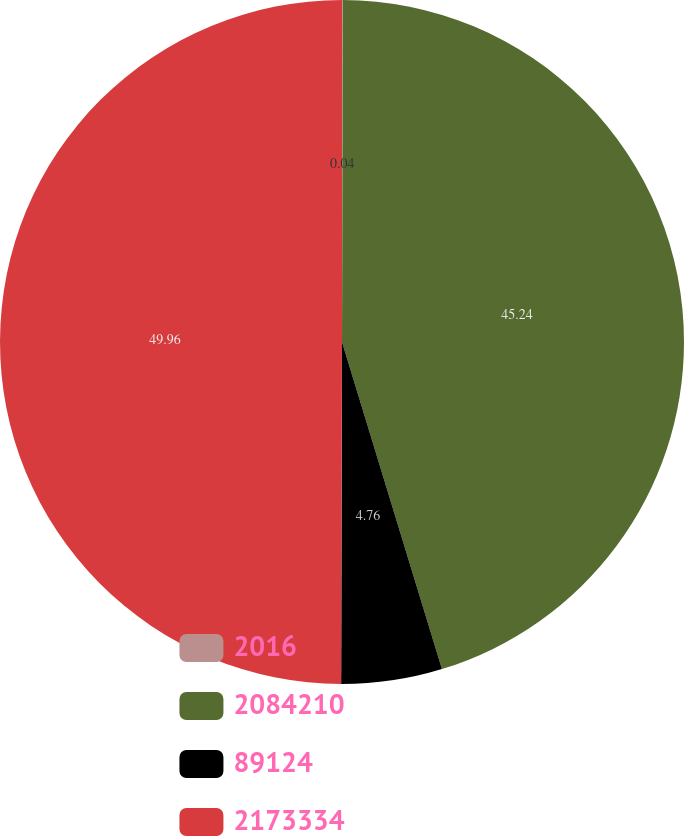Convert chart to OTSL. <chart><loc_0><loc_0><loc_500><loc_500><pie_chart><fcel>2016<fcel>2084210<fcel>89124<fcel>2173334<nl><fcel>0.04%<fcel>45.24%<fcel>4.76%<fcel>49.96%<nl></chart> 